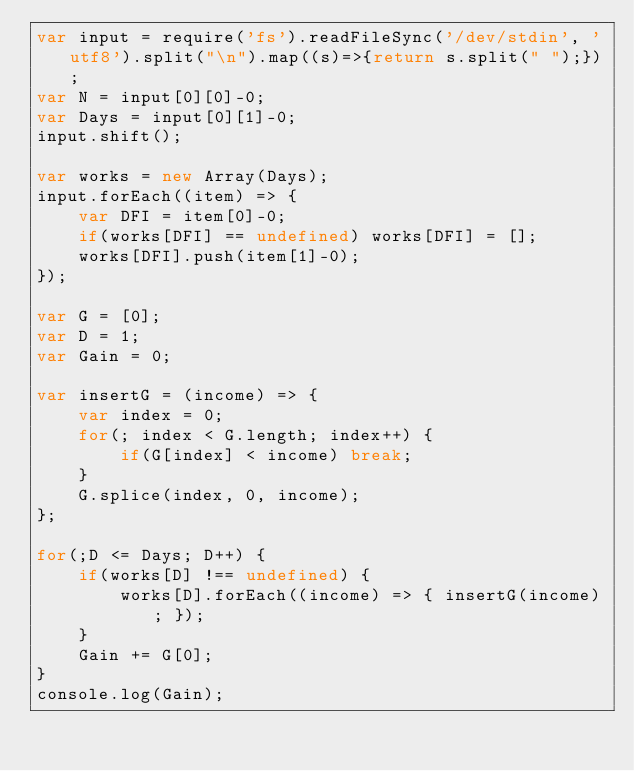<code> <loc_0><loc_0><loc_500><loc_500><_JavaScript_>var input = require('fs').readFileSync('/dev/stdin', 'utf8').split("\n").map((s)=>{return s.split(" ");});
var N = input[0][0]-0;
var Days = input[0][1]-0;
input.shift();

var works = new Array(Days);
input.forEach((item) => {
	var DFI = item[0]-0;
	if(works[DFI] == undefined) works[DFI] = [];
	works[DFI].push(item[1]-0);
});

var G = [0];
var D = 1;
var Gain = 0;

var insertG = (income) => {
	var index = 0;
	for(; index < G.length; index++) {
		if(G[index] < income) break;
	}
	G.splice(index, 0, income);
};

for(;D <= Days; D++) {
	if(works[D] !== undefined) {
		works[D].forEach((income) => { insertG(income); });
	}	
	Gain += G[0];
}
console.log(Gain);
</code> 